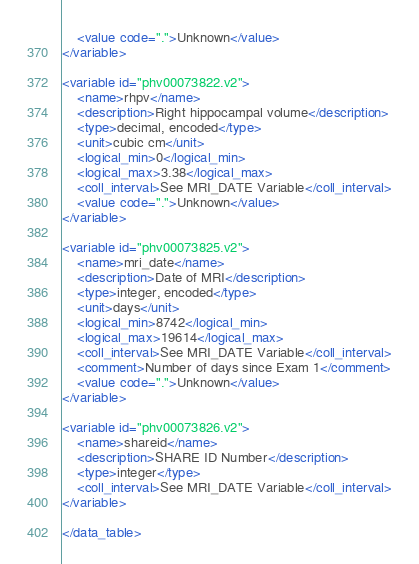<code> <loc_0><loc_0><loc_500><loc_500><_XML_>	<value code=".">Unknown</value>
</variable>

<variable id="phv00073822.v2">
	<name>rhpv</name>
	<description>Right hippocampal volume</description>
	<type>decimal, encoded</type>
	<unit>cubic cm</unit>
	<logical_min>0</logical_min>
	<logical_max>3.38</logical_max>
	<coll_interval>See MRI_DATE Variable</coll_interval>
	<value code=".">Unknown</value>
</variable>

<variable id="phv00073825.v2">
	<name>mri_date</name>
	<description>Date of MRI</description>
	<type>integer, encoded</type>
	<unit>days</unit>
	<logical_min>8742</logical_min>
	<logical_max>19614</logical_max>
	<coll_interval>See MRI_DATE Variable</coll_interval>
	<comment>Number of days since Exam 1</comment>
	<value code=".">Unknown</value>
</variable>

<variable id="phv00073826.v2">
	<name>shareid</name>
	<description>SHARE ID Number</description>
	<type>integer</type>
	<coll_interval>See MRI_DATE Variable</coll_interval>
</variable>

</data_table>
</code> 